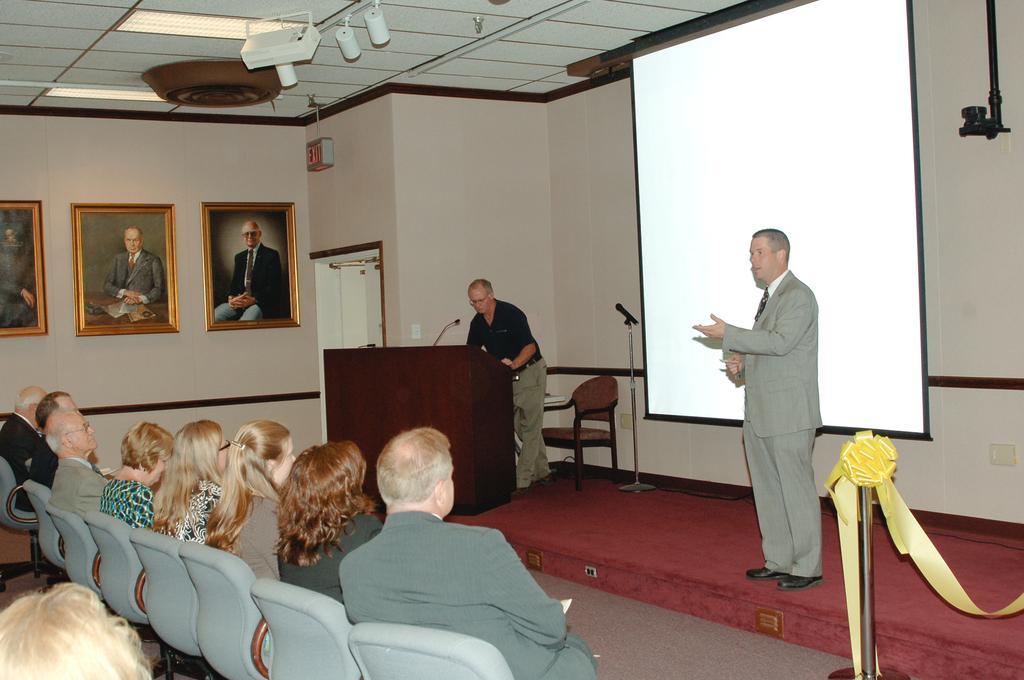Describe this image in one or two sentences. The picture is taken inside a hall where one man is standing on the stage in a grey suit and behind him there is one screen and at the left corner of the picture one person is standing in front of the podium and there is a chair and there is one door and there are people sitting in the chairs and beside them there is a wall and some photographs on it and there is one exit sign board. 